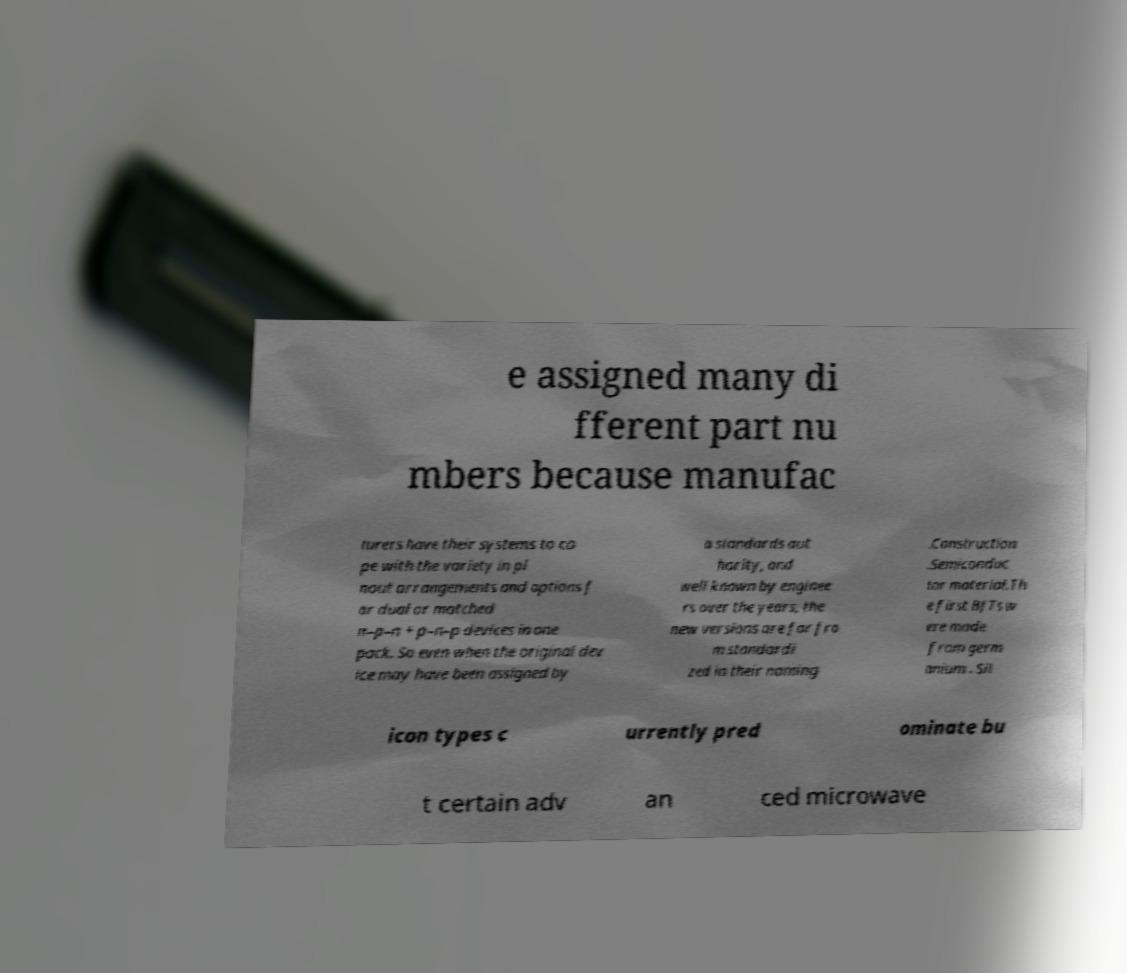Can you accurately transcribe the text from the provided image for me? e assigned many di fferent part nu mbers because manufac turers have their systems to co pe with the variety in pi nout arrangements and options f or dual or matched n–p–n + p–n–p devices in one pack. So even when the original dev ice may have been assigned by a standards aut hority, and well known by enginee rs over the years, the new versions are far fro m standardi zed in their naming .Construction .Semiconduc tor material.Th e first BJTs w ere made from germ anium . Sil icon types c urrently pred ominate bu t certain adv an ced microwave 